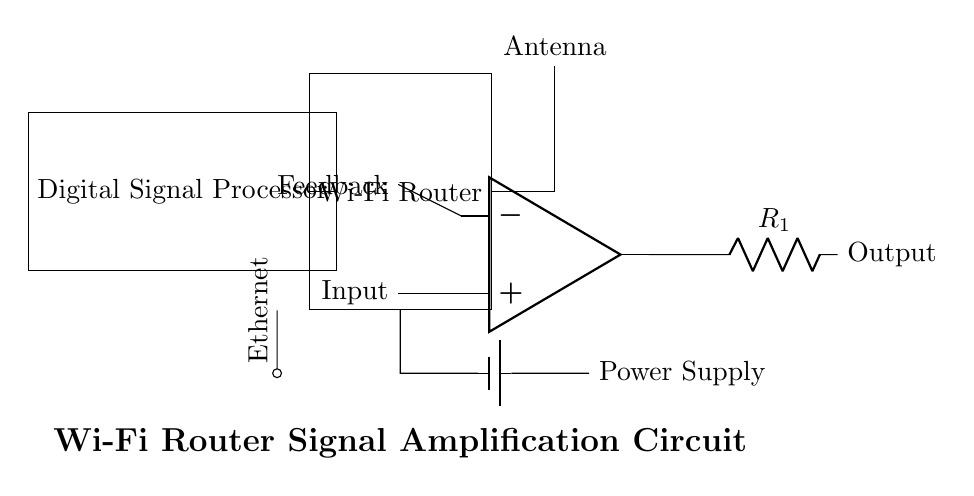What is the primary component used for signal amplification? The primary component for signal amplification in this circuit is the operational amplifier, which is depicted in the circuit diagram. It takes the weak input signal and boosts it for transmission through the output.
Answer: operational amplifier What is the role of the Digital Signal Processor? The Digital Signal Processor in the circuit processes incoming digital data before it is sent to the Wi-Fi router, preparing the data for efficient transmission. It ensures that the signal is in the right format and optimized for amplification.
Answer: signal processing How is the power supplied to the circuit? The circuit is powered by a battery, which is visually represented in the diagram. The battery connects to the router, indicating it supplies the necessary energy for the operation of the router and its components.
Answer: battery What type of connection is represented by the component labeled "Ethernet"? The Ethernet component represents a physical wired connection used to connect the router to other devices, such as computers or switches, enabling wired network communication.
Answer: wired connection What does the feedback loop in the operational amplifier achieve? The feedback loop in the operational amplifier stabilizes the gain and improves the linearity of the amplification, ensuring that the output signal maintains quality and does not distort.
Answer: stability and quality What is the function of the antenna in this circuit? The antenna's function is to transmit and receive wireless signals, allowing the router to communicate with devices over Wi-Fi. It converts electrical signals from the router into radio waves and vice versa.
Answer: communication How many components are directly connected to the router? The components directly connected to the router include the operational amplifier, Digital Signal Processor, power supply, and Ethernet port, totaling four connections.
Answer: four 